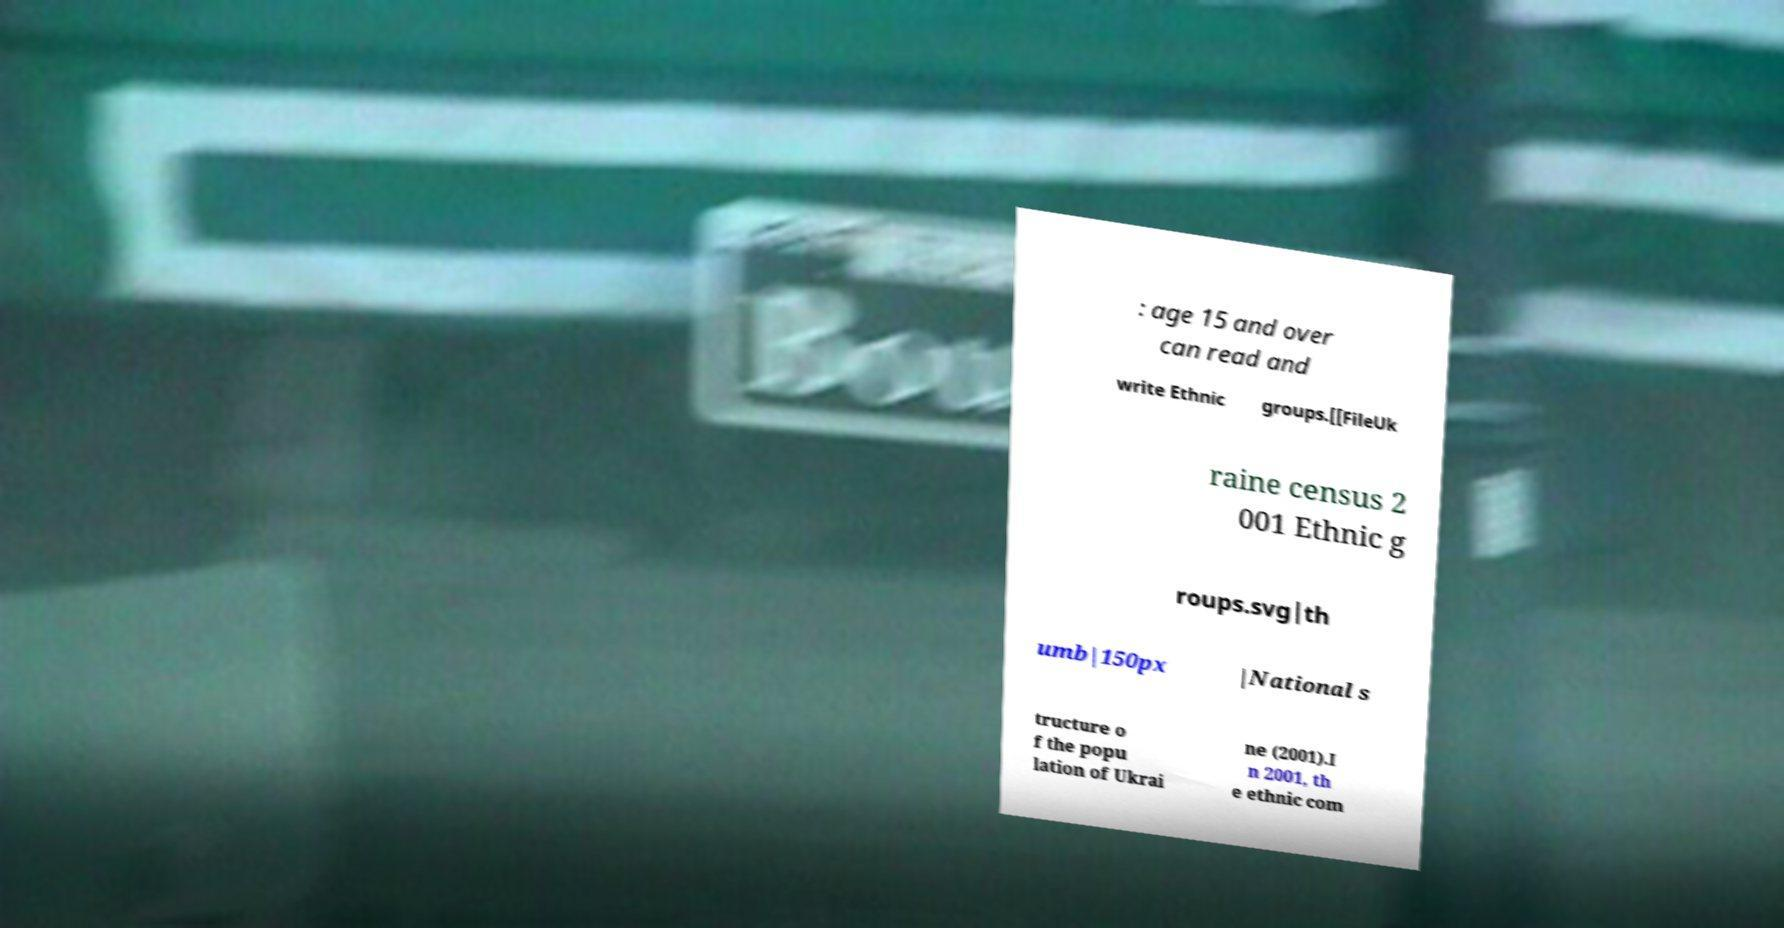What messages or text are displayed in this image? I need them in a readable, typed format. : age 15 and over can read and write Ethnic groups.[[FileUk raine census 2 001 Ethnic g roups.svg|th umb|150px |National s tructure o f the popu lation of Ukrai ne (2001).I n 2001, th e ethnic com 